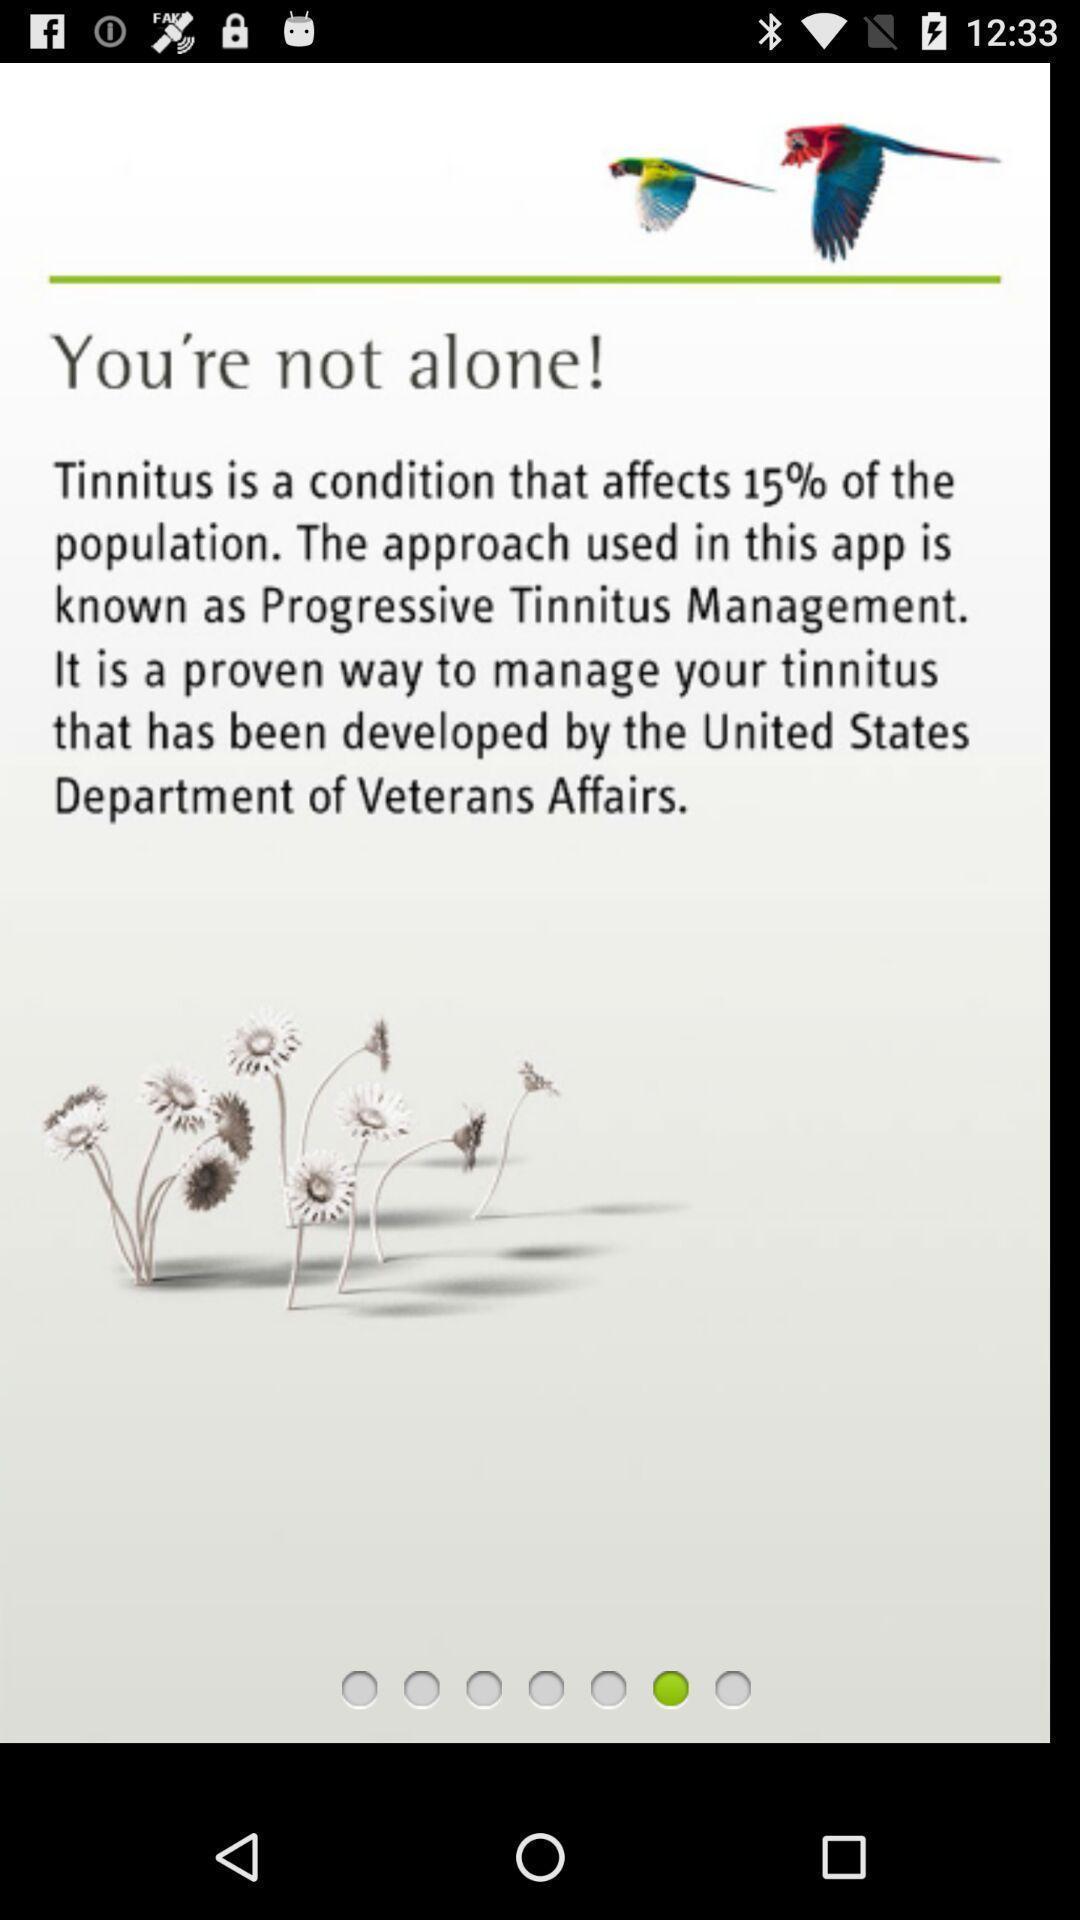Provide a description of this screenshot. Welcome page for a sound plan app. 